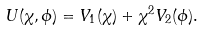<formula> <loc_0><loc_0><loc_500><loc_500>U ( \chi , \phi ) = V _ { 1 } ( \chi ) + \chi ^ { 2 } V _ { 2 } ( \phi ) .</formula> 